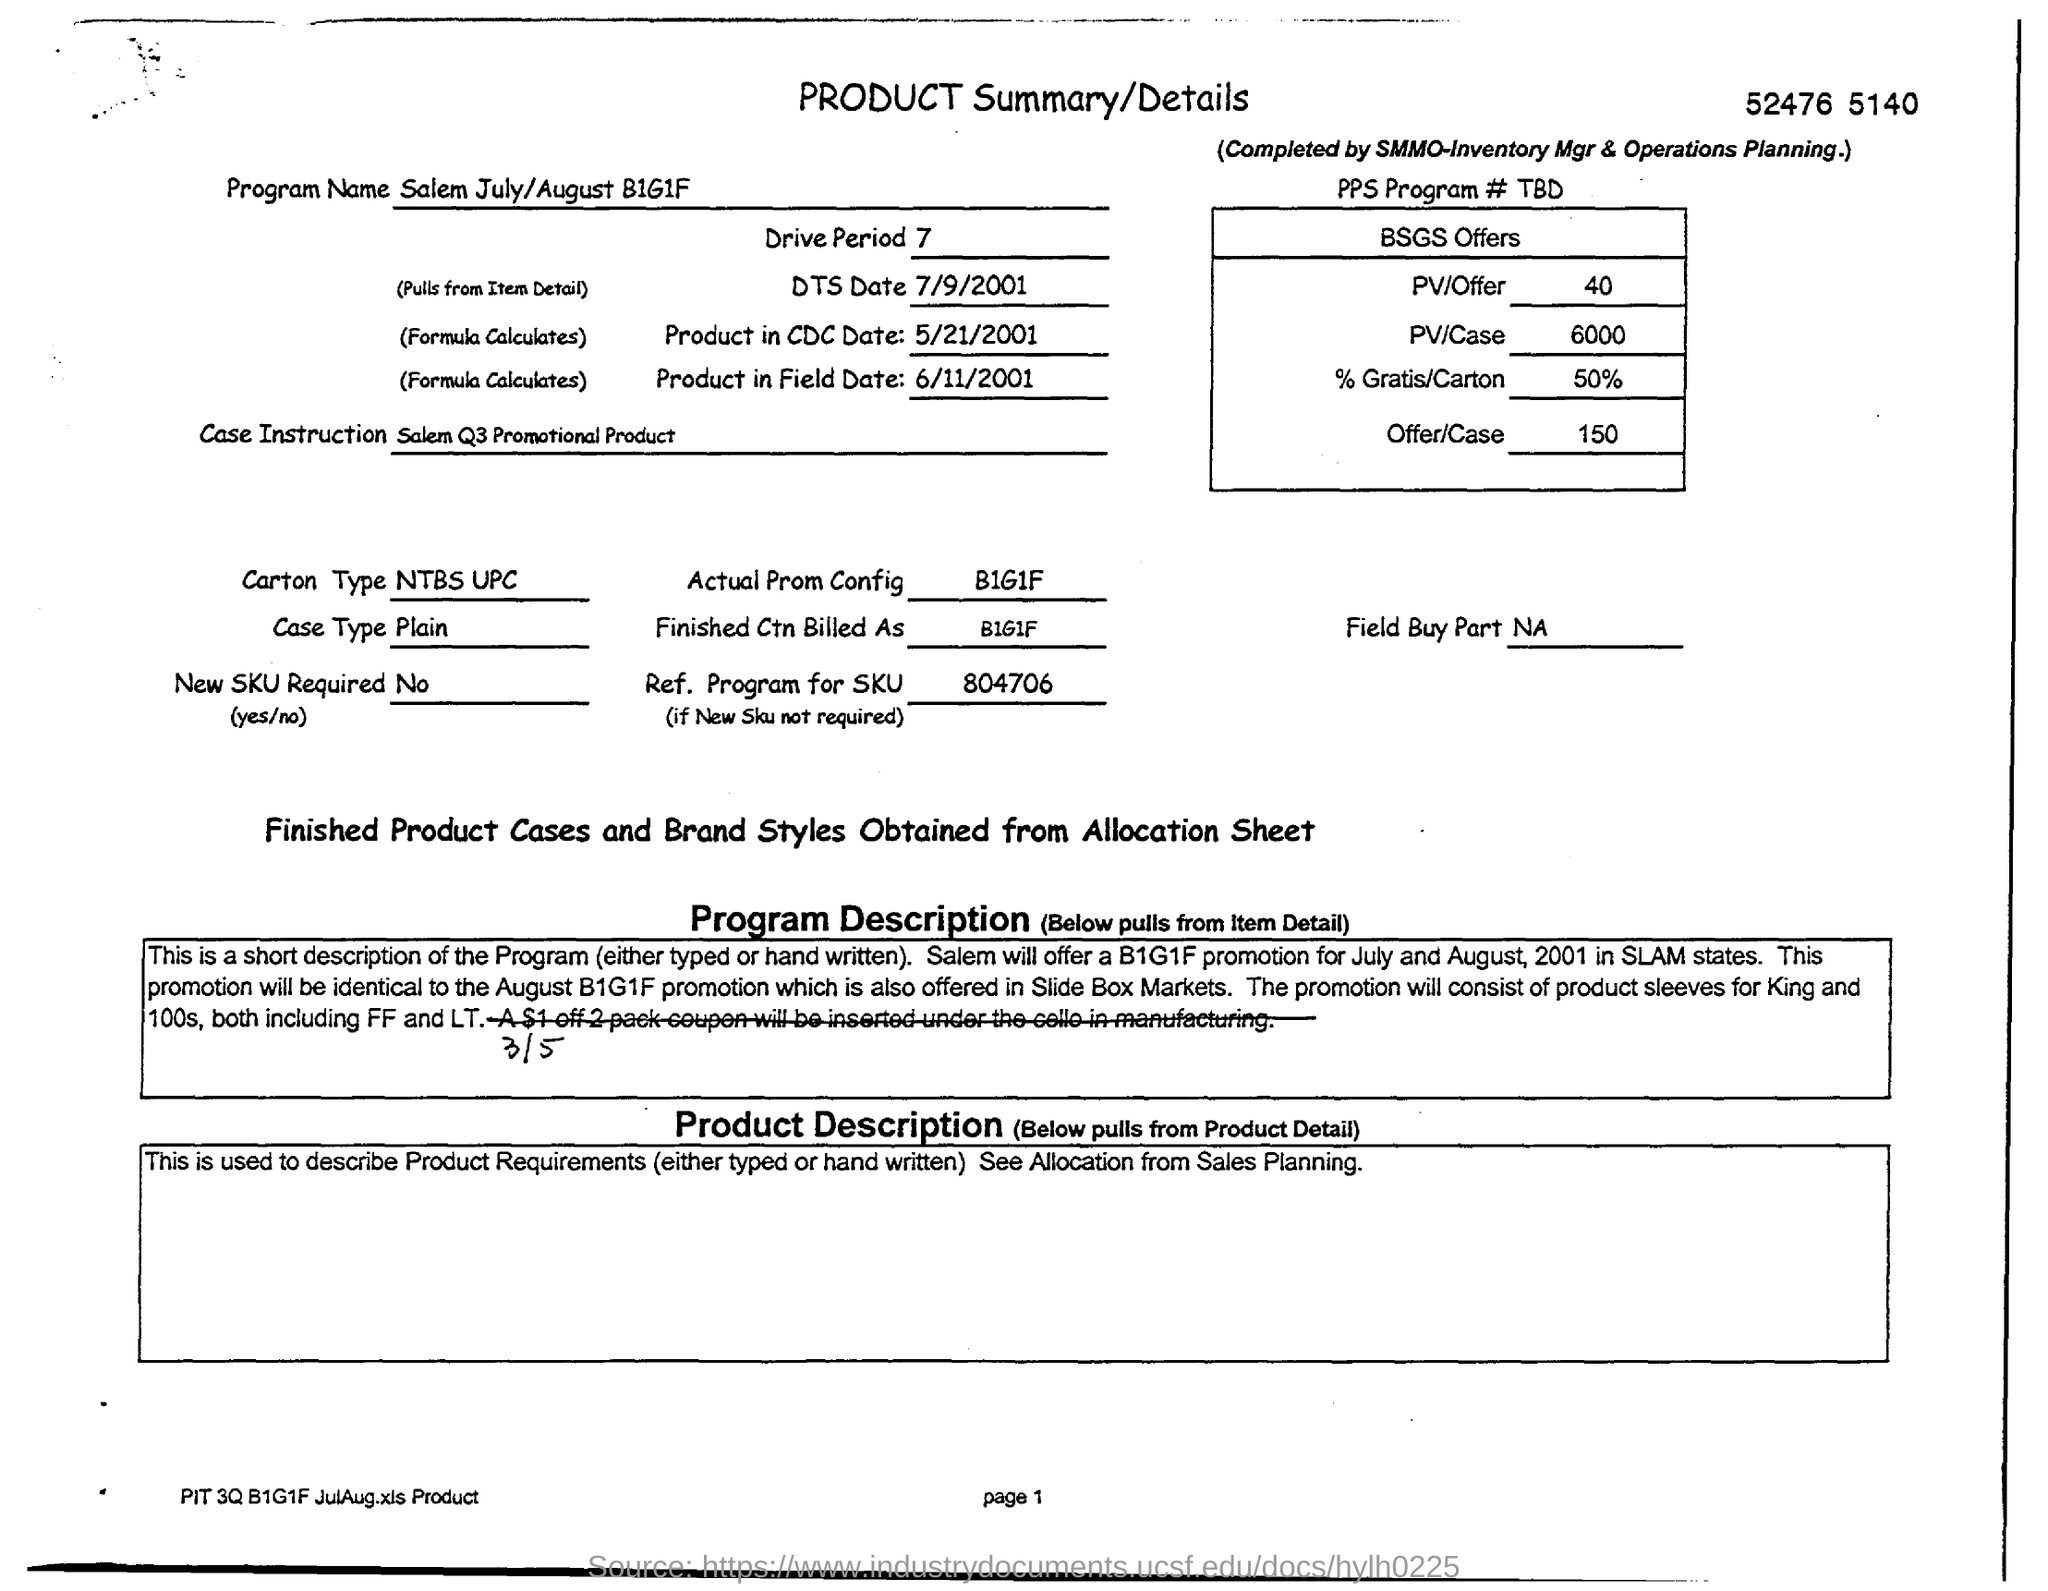What is the Carton Type?
Offer a very short reply. NTBS UPC. What is the Case Type?
Keep it short and to the point. Plain. What is the Drive Period?
Offer a terse response. 7. 